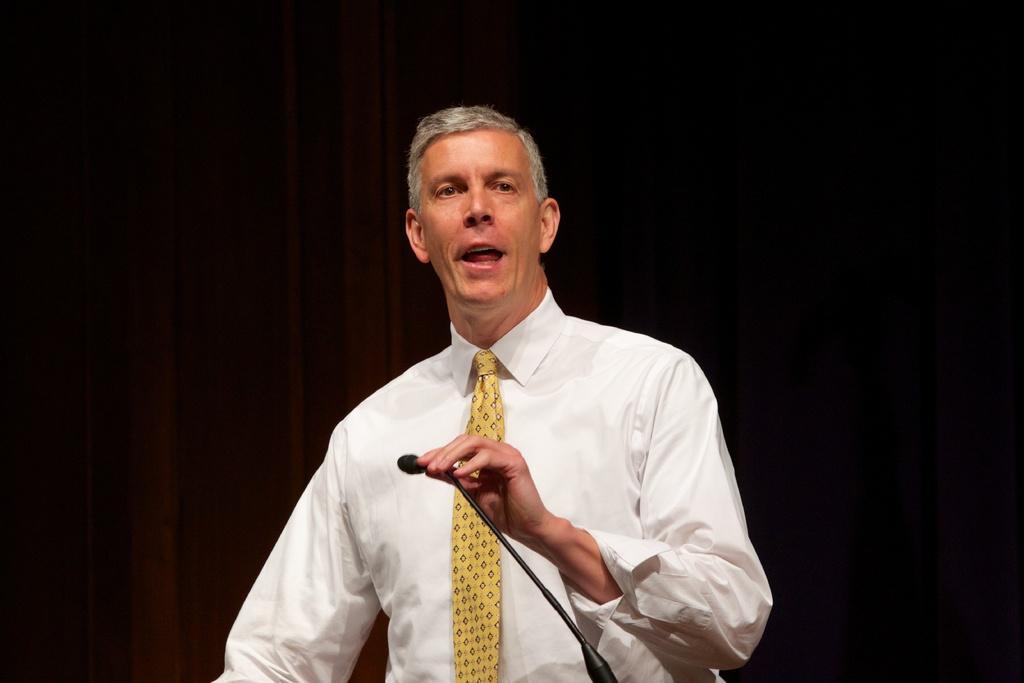In one or two sentences, can you explain what this image depicts? In this picture we can see a man, he wore a white color shirt, in front of him we can find a microphone. 